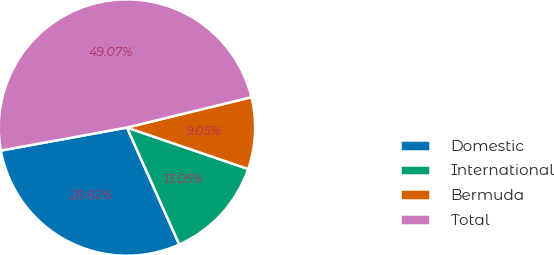Convert chart. <chart><loc_0><loc_0><loc_500><loc_500><pie_chart><fcel>Domestic<fcel>International<fcel>Bermuda<fcel>Total<nl><fcel>28.82%<fcel>13.05%<fcel>9.05%<fcel>49.07%<nl></chart> 